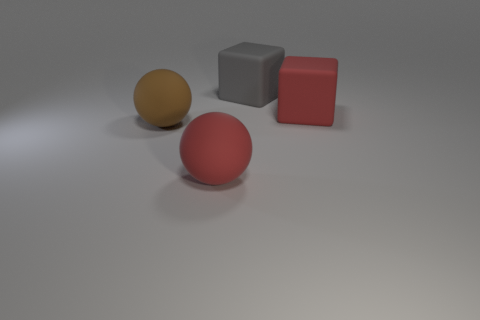What color is the large cube that is made of the same material as the large gray thing?
Keep it short and to the point. Red. What number of objects are either large red matte objects or cubes?
Provide a short and direct response. 3. The gray object that is the same size as the brown ball is what shape?
Keep it short and to the point. Cube. What number of big objects are in front of the red rubber block and behind the large red ball?
Keep it short and to the point. 1. What is the material of the red object left of the large gray object?
Offer a terse response. Rubber. There is a red sphere that is the same material as the large brown ball; what is its size?
Make the answer very short. Large. Is the size of the red object to the left of the red block the same as the red matte thing that is behind the big brown rubber object?
Offer a terse response. Yes. There is a brown thing that is the same size as the red matte cube; what is it made of?
Offer a terse response. Rubber. There is a object that is left of the large gray rubber thing and behind the big red matte ball; what material is it made of?
Keep it short and to the point. Rubber. Are there any large things?
Your answer should be very brief. Yes. 